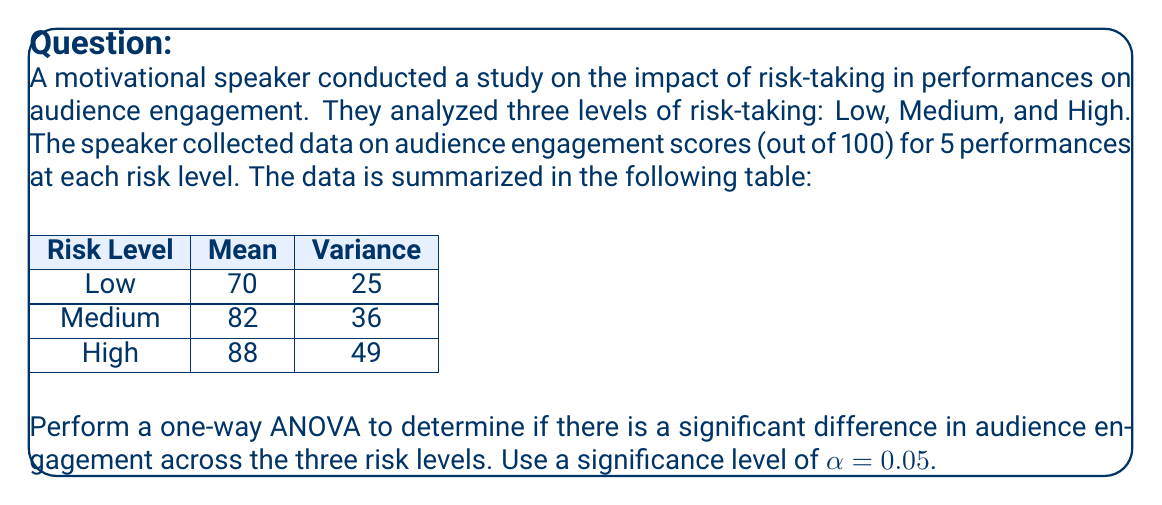Give your solution to this math problem. Let's perform the one-way ANOVA step-by-step:

1) First, we need to calculate the following:
   - Grand Mean
   - Sum of Squares Total (SST)
   - Sum of Squares Between (SSB)
   - Sum of Squares Within (SSW)
   - Degrees of Freedom (df)
   - Mean Square Between (MSB)
   - Mean Square Within (MSW)
   - F-statistic

2) Grand Mean:
   $\bar{X} = \frac{70 + 82 + 88}{3} = 80$

3) SSB:
   $SSB = \sum_{i=1}^{k} n_i(\bar{X_i} - \bar{X})^2$
   $SSB = 5[(70-80)^2 + (82-80)^2 + (88-80)^2]$
   $SSB = 5(100 + 4 + 64) = 840$

4) SSW:
   $SSW = \sum_{i=1}^{k} (n_i - 1)s_i^2$
   $SSW = 4(25 + 36 + 49) = 440$

5) SST:
   $SST = SSB + SSW = 840 + 440 = 1280$

6) Degrees of Freedom:
   $df_{between} = k - 1 = 3 - 1 = 2$
   $df_{within} = N - k = 15 - 3 = 12$
   $df_{total} = N - 1 = 15 - 1 = 14$

7) Mean Squares:
   $MSB = \frac{SSB}{df_{between}} = \frac{840}{2} = 420$
   $MSW = \frac{SSW}{df_{within}} = \frac{440}{12} \approx 36.67$

8) F-statistic:
   $F = \frac{MSB}{MSW} = \frac{420}{36.67} \approx 11.45$

9) Critical F-value:
   For α = 0.05, df_between = 2, df_within = 12, the critical F-value is approximately 3.89

10) Decision:
    Since the calculated F-statistic (11.45) is greater than the critical F-value (3.89), we reject the null hypothesis.
Answer: F(2,12) = 11.45, p < 0.05. Significant difference in audience engagement across risk levels. 